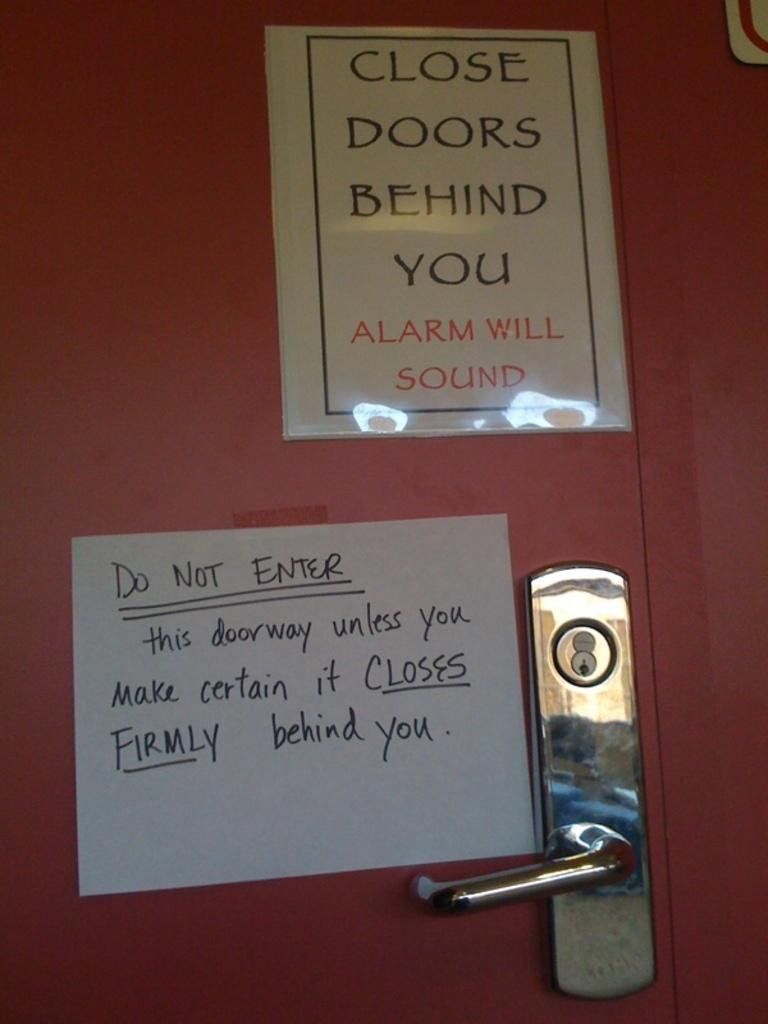<image>
Describe the image concisely. A sign on the door warns that an alarm will sound if you don't close the door. 